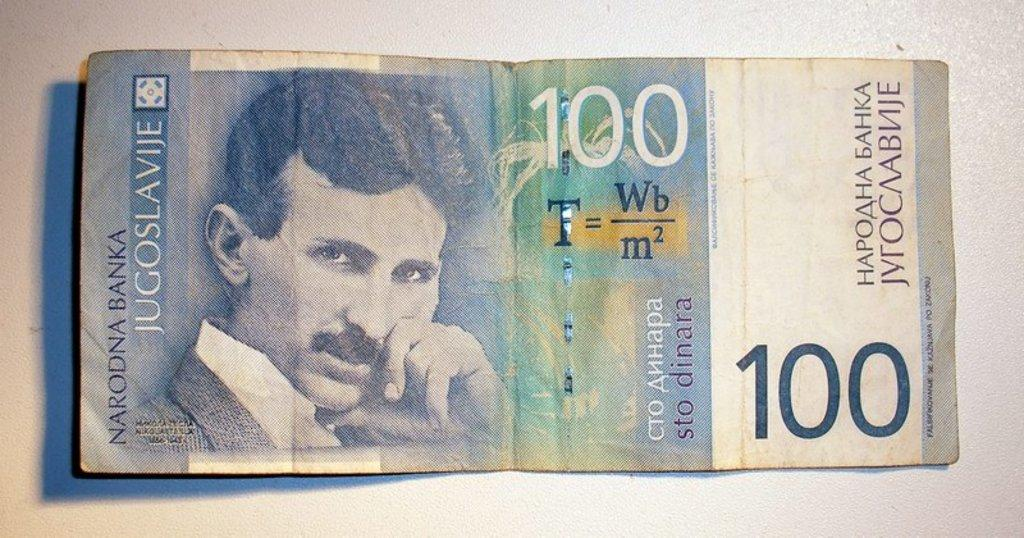Who or what is present in the image? There is a person in the image. What else can be seen in the image besides the person? There is a currency note in the image. Can you describe the currency note? The currency note has text and numbers on it. Where is the currency note located in the image? The currency note is visible on a white surface. What type of war is depicted in the image? There is no war depicted in the image; it features a person and a currency note on a white surface. How intense is the rainstorm in the image? There is no rainstorm present in the image; it is a person and a currency note on a white surface. 